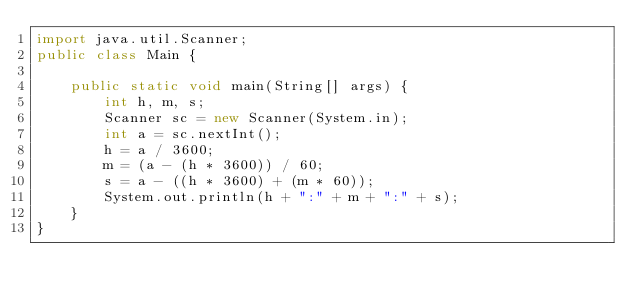Convert code to text. <code><loc_0><loc_0><loc_500><loc_500><_Java_>import java.util.Scanner;
public class Main {

	public static void main(String[] args) {
		int h, m, s;
		Scanner sc = new Scanner(System.in);
		int a = sc.nextInt();
		h = a / 3600;
		m = (a - (h * 3600)) / 60;
		s = a - ((h * 3600) + (m * 60));
		System.out.println(h + ":" + m + ":" + s);
	}
}</code> 